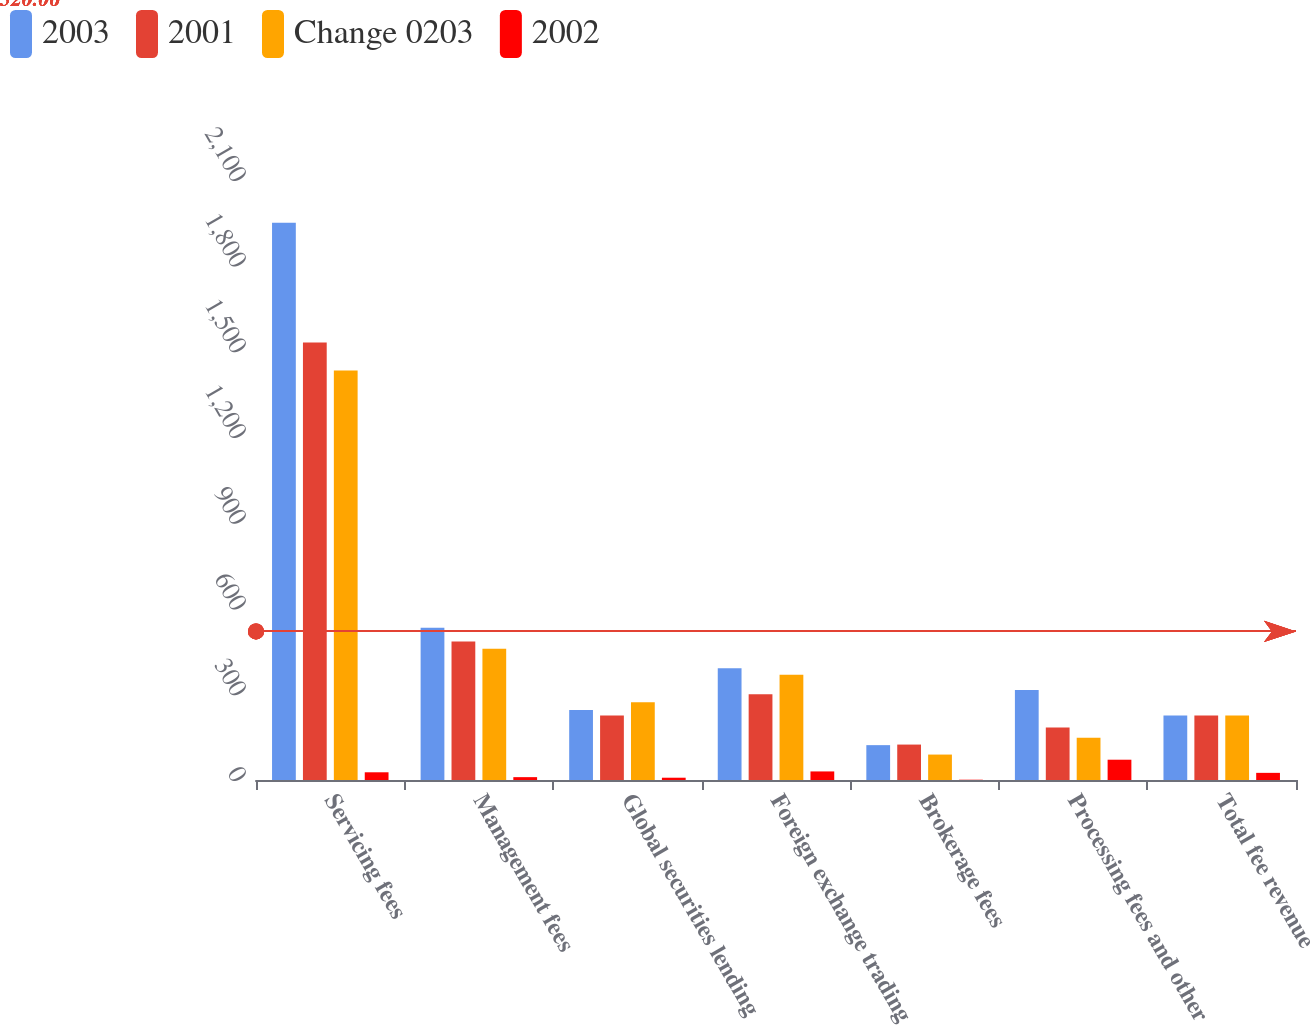<chart> <loc_0><loc_0><loc_500><loc_500><stacked_bar_chart><ecel><fcel>Servicing fees<fcel>Management fees<fcel>Global securities lending<fcel>Foreign exchange trading<fcel>Brokerage fees<fcel>Processing fees and other<fcel>Total fee revenue<nl><fcel>2003<fcel>1950<fcel>533<fcel>245<fcel>391<fcel>122<fcel>315<fcel>226<nl><fcel>2001<fcel>1531<fcel>485<fcel>226<fcel>300<fcel>124<fcel>184<fcel>226<nl><fcel>Change 0203<fcel>1433<fcel>459<fcel>272<fcel>368<fcel>89<fcel>148<fcel>226<nl><fcel>2002<fcel>27<fcel>10<fcel>8<fcel>30<fcel>1<fcel>71<fcel>25<nl></chart> 